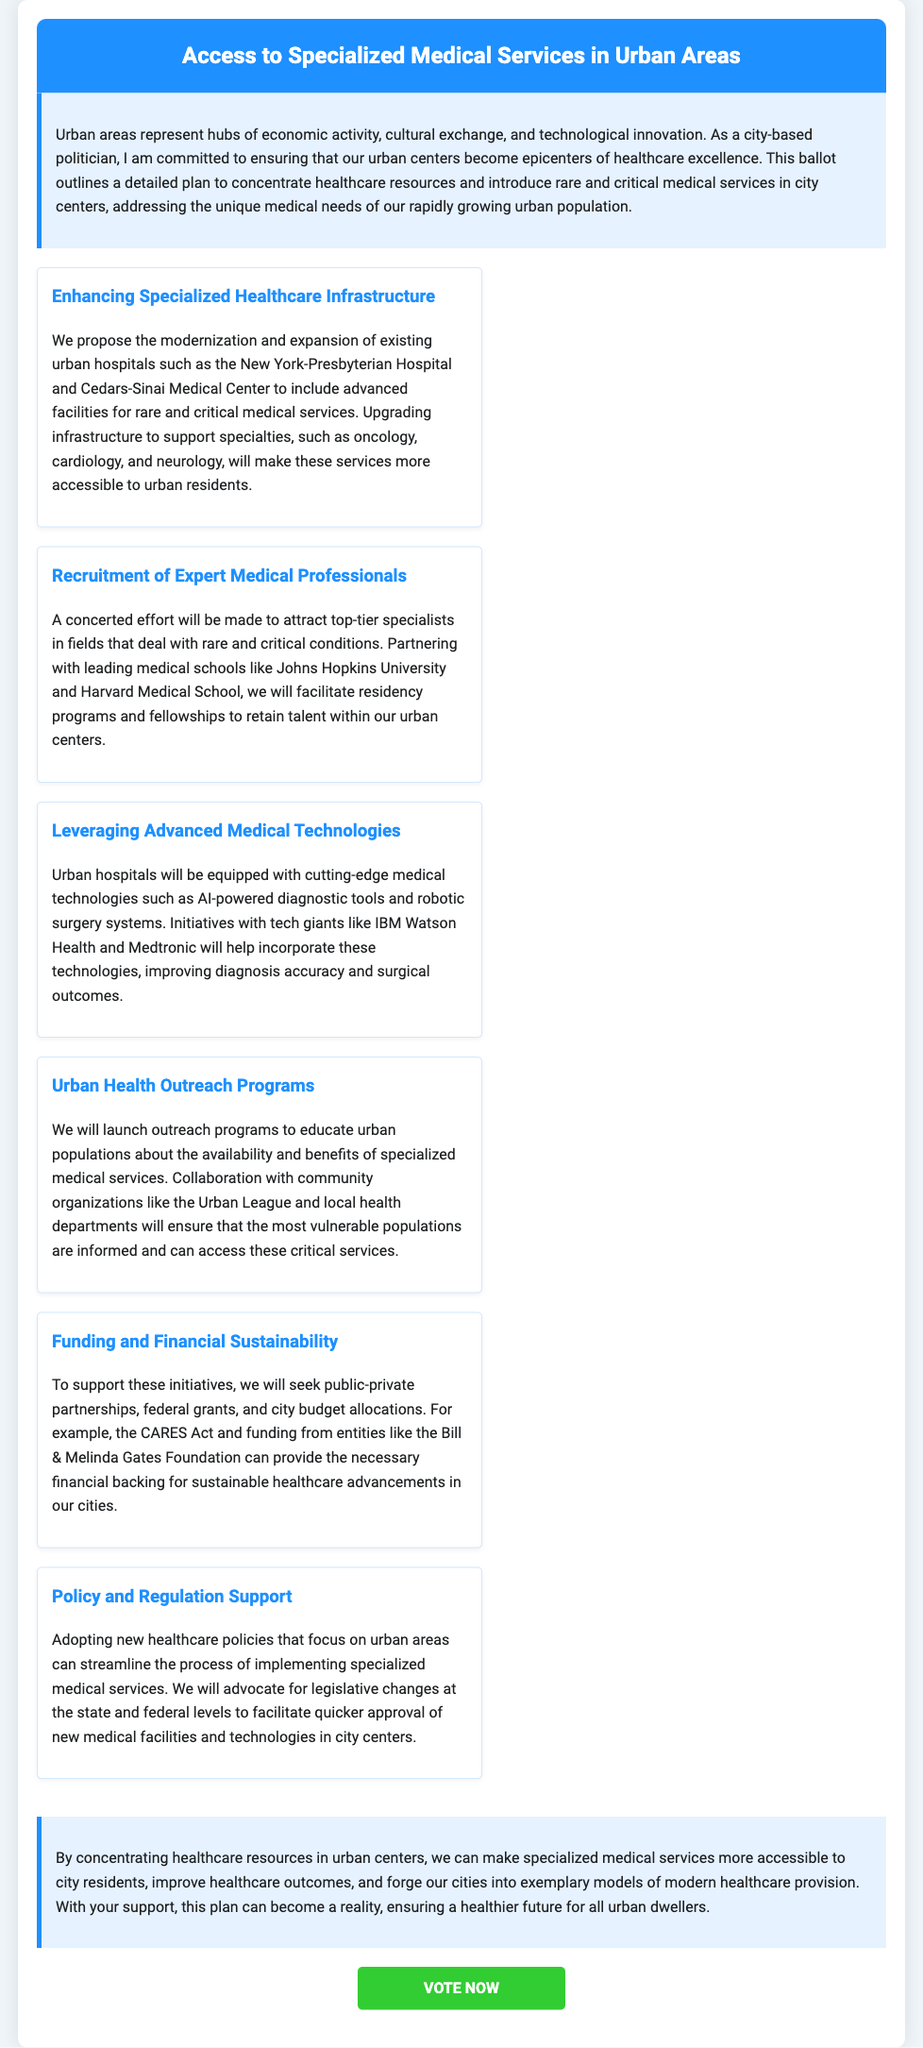What is the title of the ballot? The title of the ballot is prominently displayed in the header section of the document.
Answer: Access to Specialized Medical Services in Urban Areas What is one proposed area for healthcare infrastructure enhancement? The document specifies certain hospitals as examples of where enhancements will occur.
Answer: New York-Presbyterian Hospital What is a focus of the recruitment initiative for medical professionals? The document mentions partnering with specific institutions for residency programs to attract specialists.
Answer: Johns Hopkins University What type of technology will urban hospitals incorporate? The document discusses incorporating modern technological tools to improve healthcare delivery.
Answer: AI-powered diagnostic tools Which organization will be involved in educating urban populations about healthcare services? The document lists a community organization that will collaborate on outreach programs.
Answer: Urban League What is a funding source mentioned for the healthcare initiatives? The document references a specific act that can provide financial support for healthcare advancements.
Answer: CARES Act What is the primary goal of the proposed plan in the ballot? The document outlines an overarching aim related to the accessibility of medical services.
Answer: Make specialized medical services more accessible What aspect of healthcare policy is emphasized in the ballot? The document highlights the importance of legislative changes to support healthcare service implementation.
Answer: Policy and Regulation Support What is a key outcome expected from concentrating healthcare resources in urban areas? The document mentions a desired effect of the proposed plan on urban healthcare outcomes.
Answer: Improve healthcare outcomes 